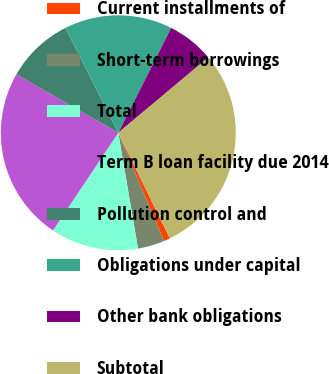Convert chart to OTSL. <chart><loc_0><loc_0><loc_500><loc_500><pie_chart><fcel>Current installments of<fcel>Short-term borrowings<fcel>Total<fcel>Term B loan facility due 2014<fcel>Pollution control and<fcel>Obligations under capital<fcel>Other bank obligations<fcel>Subtotal<nl><fcel>0.88%<fcel>3.67%<fcel>12.07%<fcel>23.91%<fcel>9.27%<fcel>14.87%<fcel>6.47%<fcel>28.86%<nl></chart> 